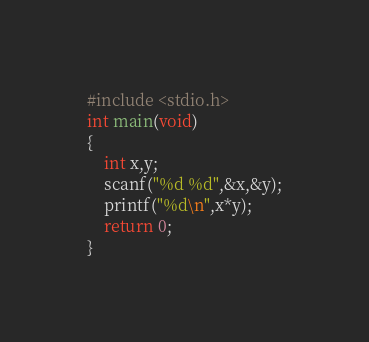Convert code to text. <code><loc_0><loc_0><loc_500><loc_500><_C_>#include <stdio.h>
int main(void)
{
    int x,y;
    scanf("%d %d",&x,&y);
    printf("%d\n",x*y);
    return 0;
}

</code> 